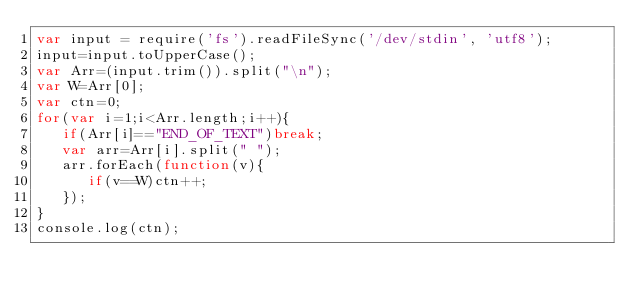Convert code to text. <code><loc_0><loc_0><loc_500><loc_500><_JavaScript_>var input = require('fs').readFileSync('/dev/stdin', 'utf8');
input=input.toUpperCase();
var Arr=(input.trim()).split("\n");
var W=Arr[0];
var ctn=0;
for(var i=1;i<Arr.length;i++){
   if(Arr[i]=="END_OF_TEXT")break;
   var arr=Arr[i].split(" ");
   arr.forEach(function(v){
      if(v==W)ctn++;
   });
}
console.log(ctn);</code> 